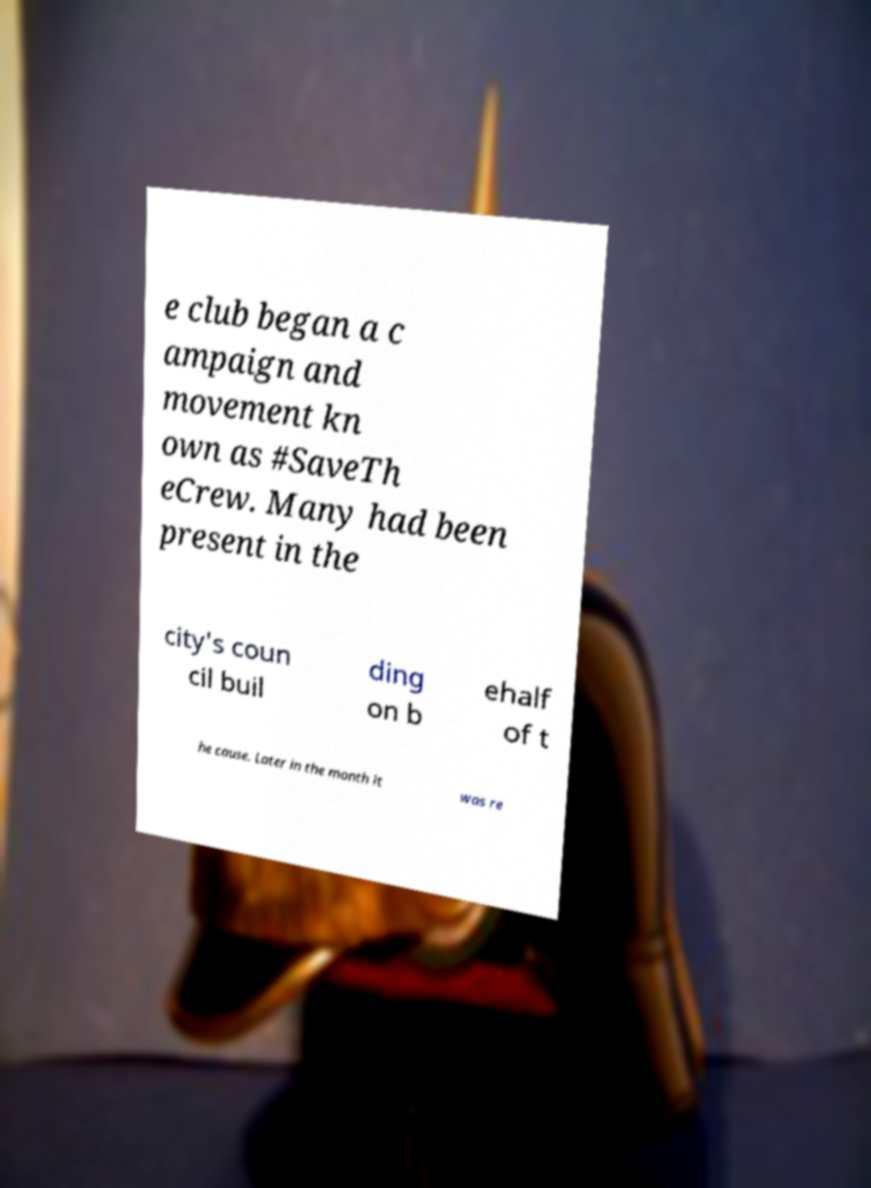Please read and relay the text visible in this image. What does it say? e club began a c ampaign and movement kn own as #SaveTh eCrew. Many had been present in the city's coun cil buil ding on b ehalf of t he cause. Later in the month it was re 